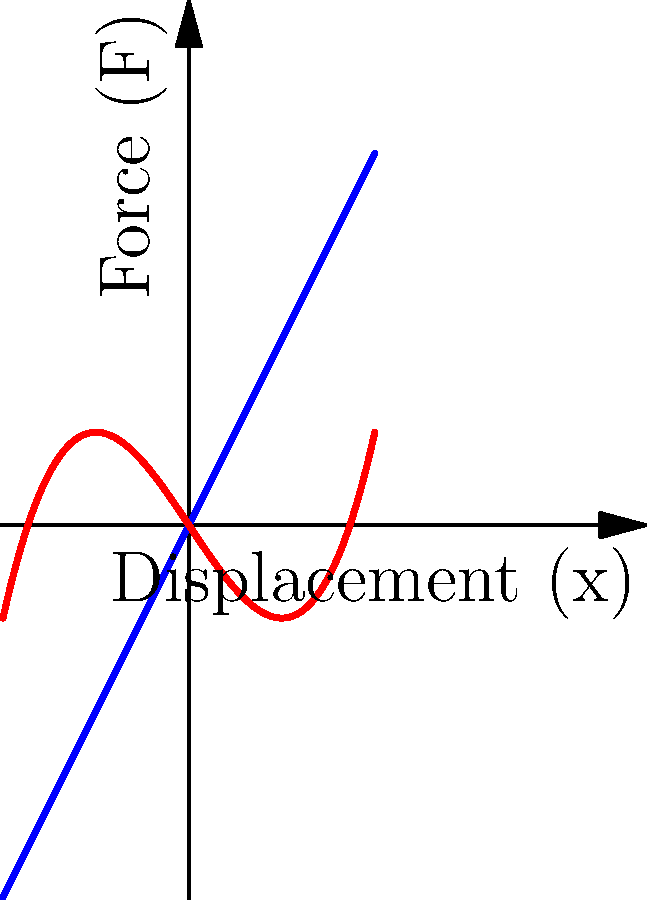In a spring-mass-damper system, the force-displacement relationship for a linear spring is given by $F = kx$, where $k$ is the spring constant. However, some environmental systems exhibit nonlinear behavior. Given the graph above showing both linear and nonlinear spring characteristics, which type of spring would be more likely to represent the elasticity of a wetland ecosystem under varying water levels, and why might this be significant in environmental law cases? To answer this question, we need to consider the characteristics of wetland ecosystems and how they respond to changes in water levels:

1. Linear spring (blue line):
   - Exhibits a constant rate of change (slope) between force and displacement
   - Follows Hooke's Law: $F = kx$
   - Represents a simple, idealized system

2. Nonlinear spring (red curve):
   - Shows a varying rate of change between force and displacement
   - Can be described by a higher-order polynomial, e.g., $F = ax^3 + bx^2 + cx + d$
   - More accurately represents complex natural systems

3. Wetland ecosystem behavior:
   - Wetlands have complex interactions between water levels, soil, and vegetation
   - Their response to water level changes is often not proportional or linear
   - They may exhibit increased resistance to change at certain thresholds

4. Environmental law implications:
   - Understanding the nonlinear nature of wetland responses is crucial for:
     a) Accurately assessing environmental impacts
     b) Determining appropriate protection measures
     c) Establishing realistic restoration goals
   - Nonlinear models can better predict ecosystem responses to extreme events or cumulative impacts

5. Significance in legal cases:
   - More accurate representation of ecosystem behavior can lead to:
     a) Better-informed policy decisions
     b) More effective environmental protection measures
     c) Stronger legal arguments in environmental litigation

Therefore, the nonlinear spring model (red curve) would more likely represent the elasticity of a wetland ecosystem under varying water levels. This nonlinear behavior is significant in environmental law cases because it provides a more accurate basis for assessing impacts, determining protection measures, and establishing restoration goals in complex ecological systems.
Answer: Nonlinear spring; better represents complex wetland ecosystem responses, crucial for accurate environmental impact assessment and informed legal arguments. 